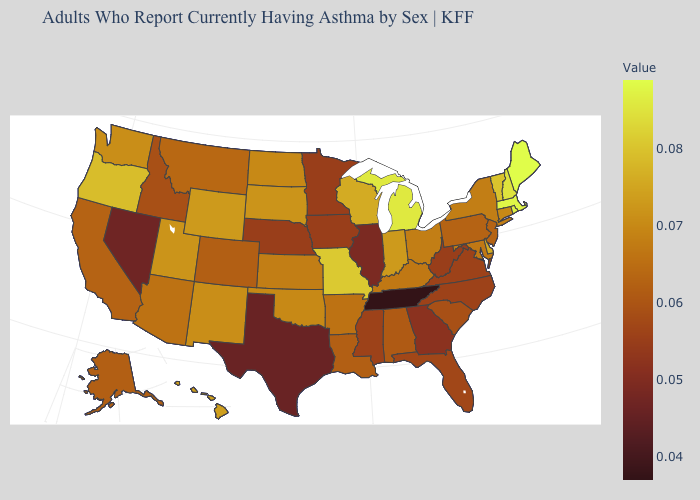Among the states that border South Carolina , does Georgia have the highest value?
Quick response, please. No. Does South Carolina have the lowest value in the South?
Give a very brief answer. No. Does Alaska have the highest value in the West?
Give a very brief answer. No. Which states hav the highest value in the South?
Answer briefly. Delaware. Among the states that border South Carolina , which have the highest value?
Give a very brief answer. North Carolina. Does Tennessee have the lowest value in the USA?
Give a very brief answer. Yes. Does Pennsylvania have the lowest value in the Northeast?
Concise answer only. Yes. 